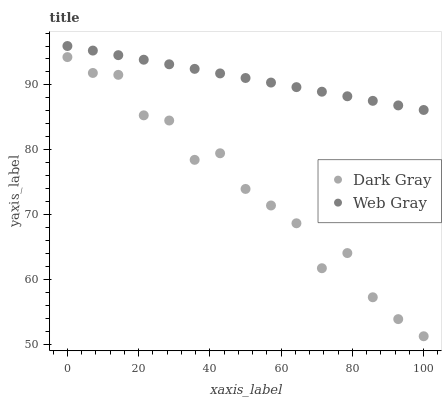Does Dark Gray have the minimum area under the curve?
Answer yes or no. Yes. Does Web Gray have the maximum area under the curve?
Answer yes or no. Yes. Does Web Gray have the minimum area under the curve?
Answer yes or no. No. Is Web Gray the smoothest?
Answer yes or no. Yes. Is Dark Gray the roughest?
Answer yes or no. Yes. Is Web Gray the roughest?
Answer yes or no. No. Does Dark Gray have the lowest value?
Answer yes or no. Yes. Does Web Gray have the lowest value?
Answer yes or no. No. Does Web Gray have the highest value?
Answer yes or no. Yes. Is Dark Gray less than Web Gray?
Answer yes or no. Yes. Is Web Gray greater than Dark Gray?
Answer yes or no. Yes. Does Dark Gray intersect Web Gray?
Answer yes or no. No. 